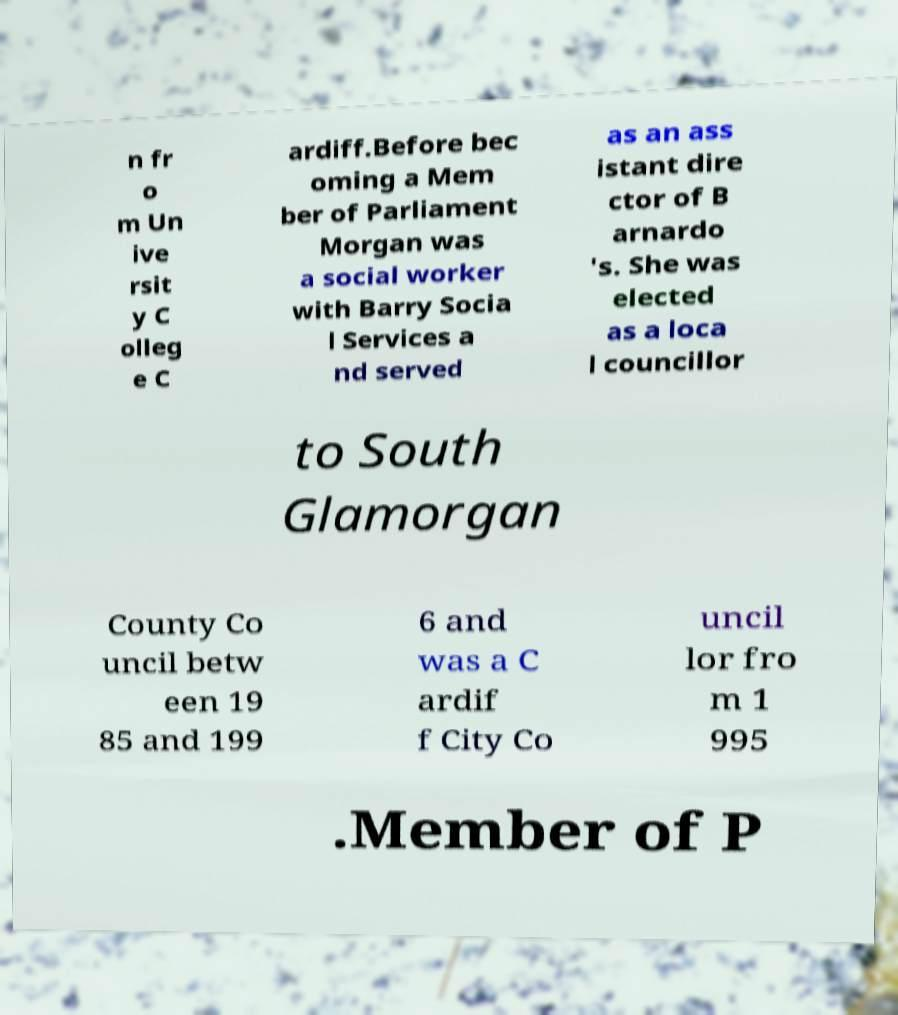Please read and relay the text visible in this image. What does it say? n fr o m Un ive rsit y C olleg e C ardiff.Before bec oming a Mem ber of Parliament Morgan was a social worker with Barry Socia l Services a nd served as an ass istant dire ctor of B arnardo 's. She was elected as a loca l councillor to South Glamorgan County Co uncil betw een 19 85 and 199 6 and was a C ardif f City Co uncil lor fro m 1 995 .Member of P 